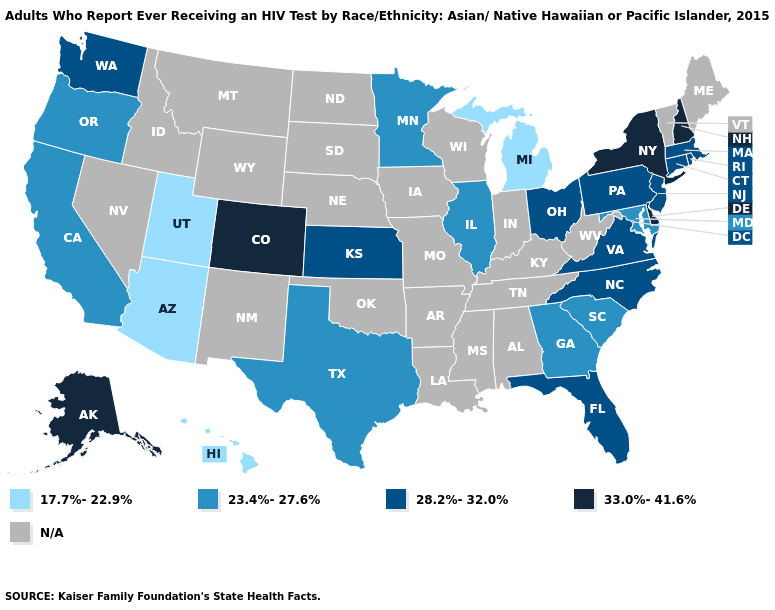Name the states that have a value in the range 28.2%-32.0%?
Concise answer only. Connecticut, Florida, Kansas, Massachusetts, New Jersey, North Carolina, Ohio, Pennsylvania, Rhode Island, Virginia, Washington. Is the legend a continuous bar?
Give a very brief answer. No. What is the value of Wyoming?
Concise answer only. N/A. Is the legend a continuous bar?
Short answer required. No. Does Kansas have the highest value in the MidWest?
Quick response, please. Yes. Name the states that have a value in the range 33.0%-41.6%?
Short answer required. Alaska, Colorado, Delaware, New Hampshire, New York. Name the states that have a value in the range 23.4%-27.6%?
Keep it brief. California, Georgia, Illinois, Maryland, Minnesota, Oregon, South Carolina, Texas. What is the lowest value in the Northeast?
Be succinct. 28.2%-32.0%. What is the lowest value in the MidWest?
Short answer required. 17.7%-22.9%. What is the value of Arizona?
Quick response, please. 17.7%-22.9%. 